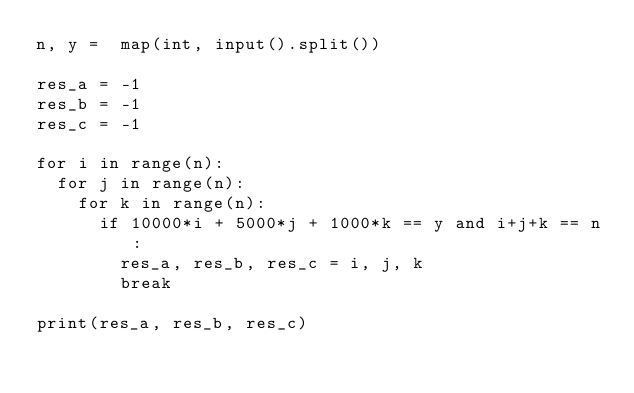Convert code to text. <code><loc_0><loc_0><loc_500><loc_500><_Python_>n, y =  map(int, input().split())

res_a = -1
res_b = -1
res_c = -1

for i in range(n):
  for j in range(n):
    for k in range(n):
      if 10000*i + 5000*j + 1000*k == y and i+j+k == n:
        res_a, res_b, res_c = i, j, k
        break
        
print(res_a, res_b, res_c)</code> 